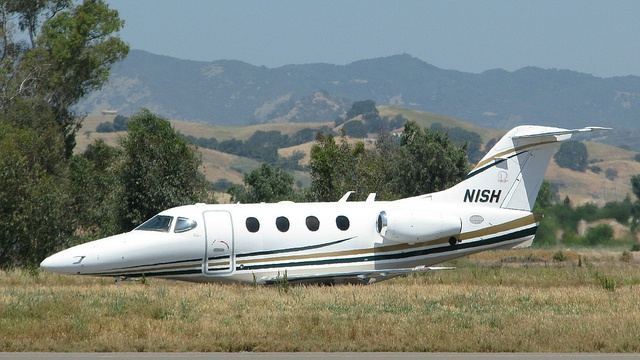Describe the objects in this image and their specific colors. I can see a airplane in darkgreen, white, gray, darkgray, and black tones in this image. 